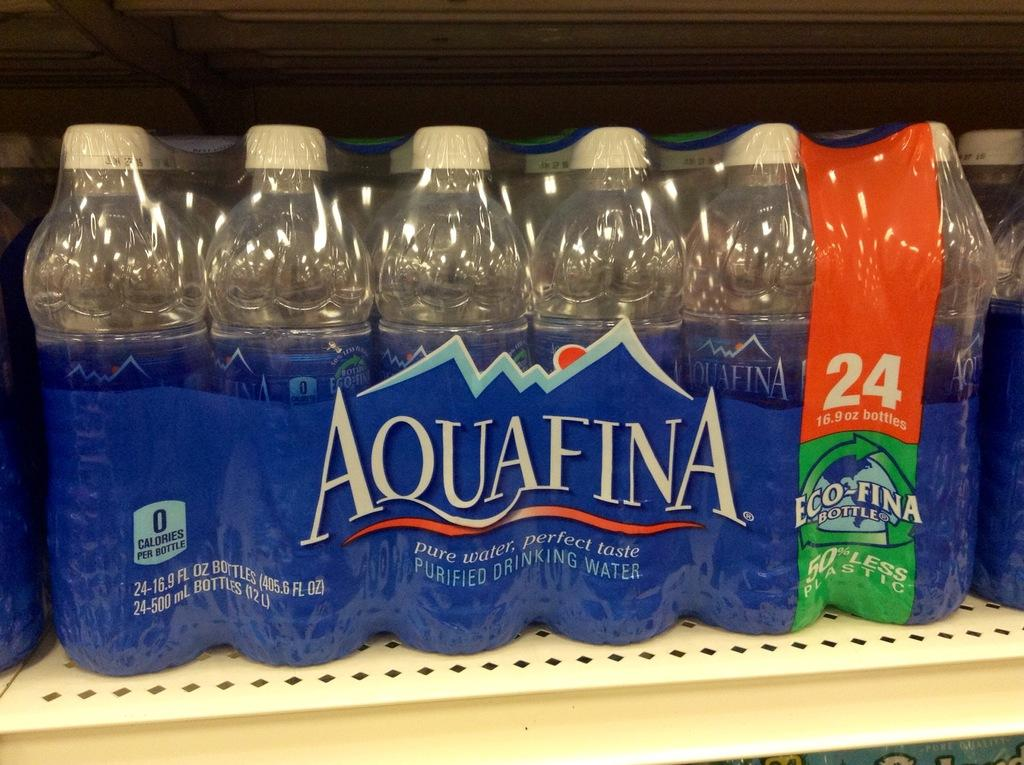<image>
Relay a brief, clear account of the picture shown. a 24 pack of Aquafina purified drinking water on a shelf 